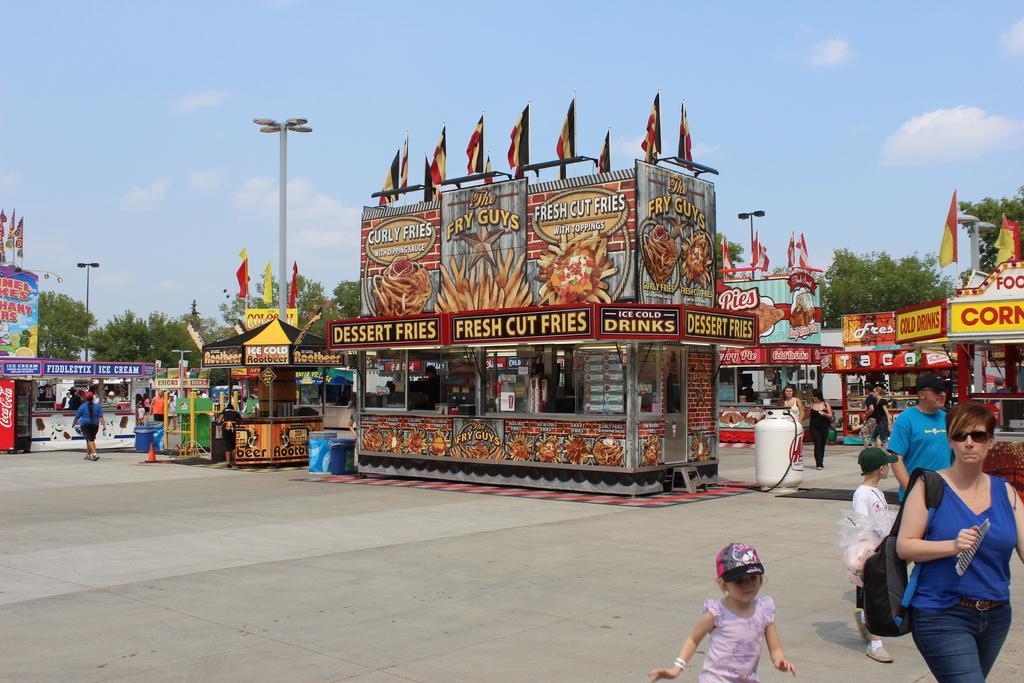How would you summarize this image in a sentence or two? In this image I can see the ground, few persons standing on the ground, a cylinder and number of stores. I can see few trees which are green in color, few flags, few poles and in the background I can see the sky. 